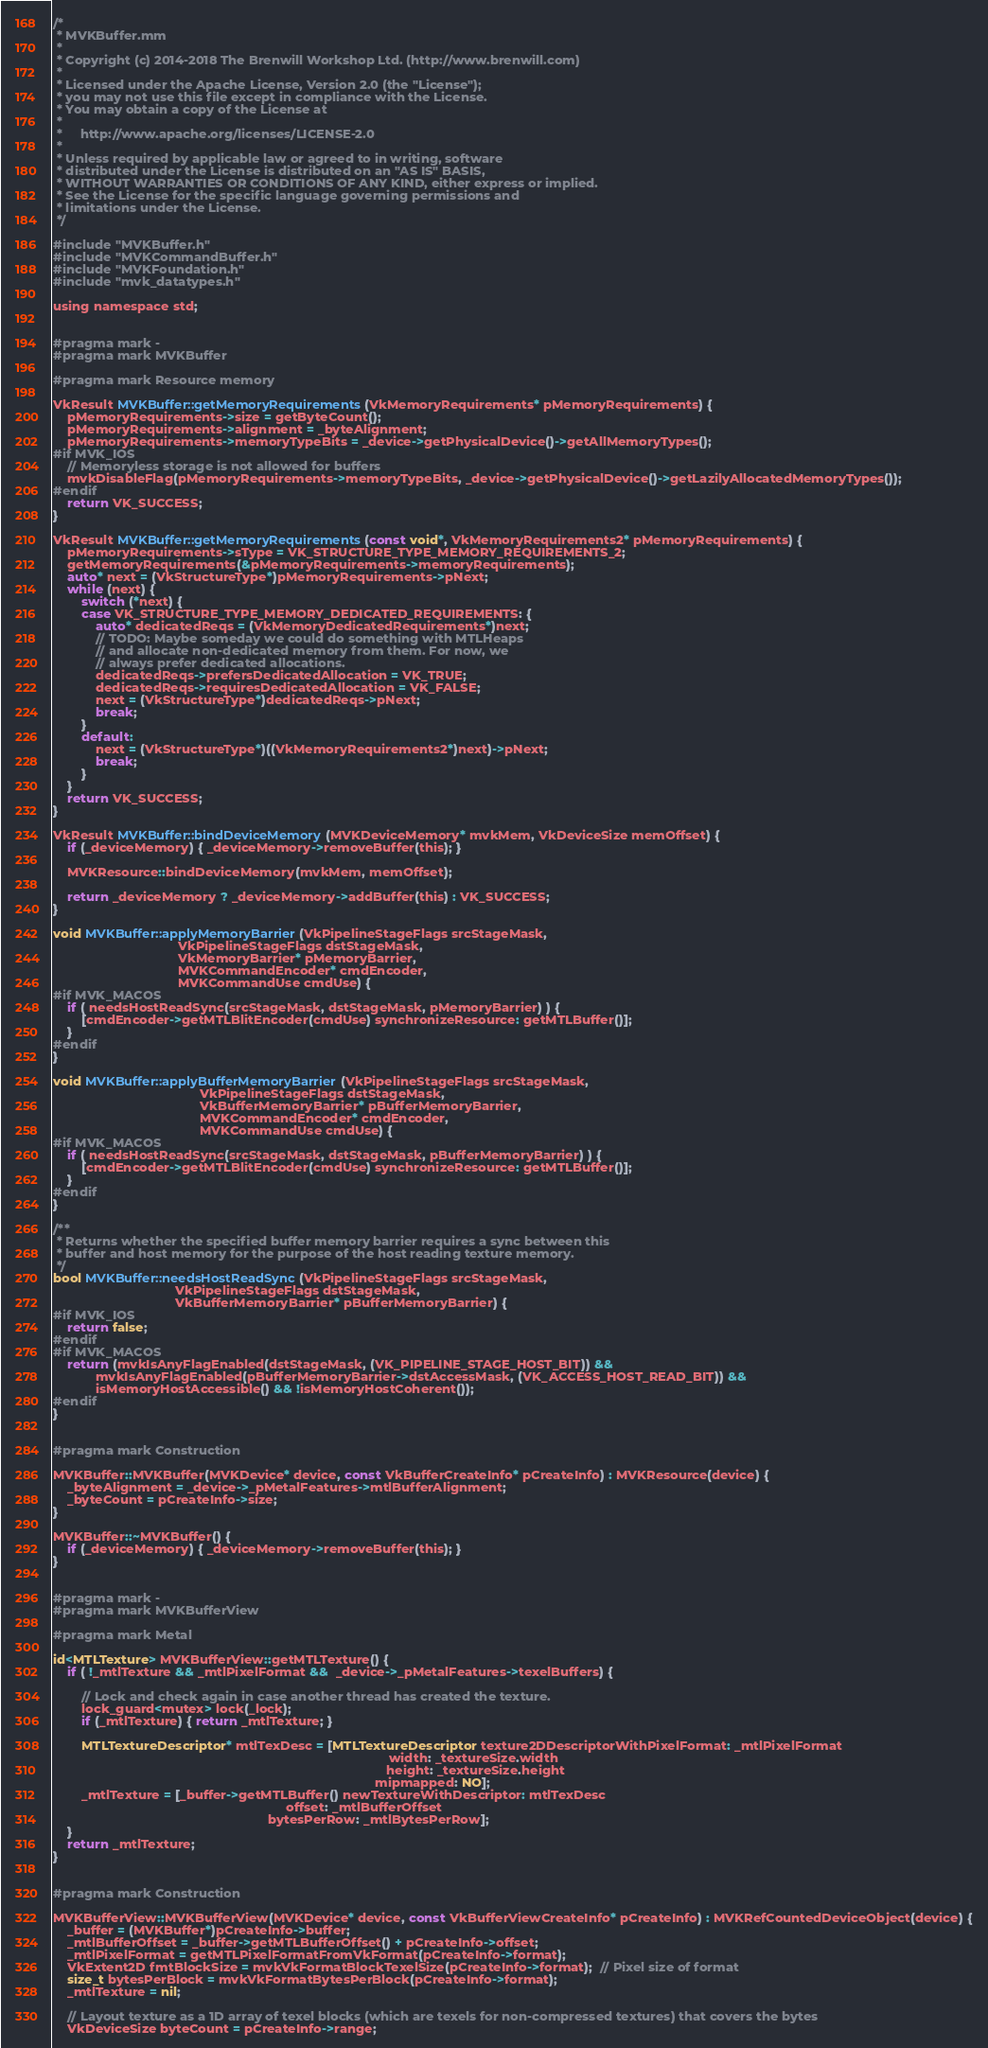Convert code to text. <code><loc_0><loc_0><loc_500><loc_500><_ObjectiveC_>/*
 * MVKBuffer.mm
 *
 * Copyright (c) 2014-2018 The Brenwill Workshop Ltd. (http://www.brenwill.com)
 *
 * Licensed under the Apache License, Version 2.0 (the "License");
 * you may not use this file except in compliance with the License.
 * You may obtain a copy of the License at
 * 
 *     http://www.apache.org/licenses/LICENSE-2.0
 * 
 * Unless required by applicable law or agreed to in writing, software
 * distributed under the License is distributed on an "AS IS" BASIS,
 * WITHOUT WARRANTIES OR CONDITIONS OF ANY KIND, either express or implied.
 * See the License for the specific language governing permissions and
 * limitations under the License.
 */

#include "MVKBuffer.h"
#include "MVKCommandBuffer.h"
#include "MVKFoundation.h"
#include "mvk_datatypes.h"

using namespace std;


#pragma mark -
#pragma mark MVKBuffer

#pragma mark Resource memory

VkResult MVKBuffer::getMemoryRequirements(VkMemoryRequirements* pMemoryRequirements) {
	pMemoryRequirements->size = getByteCount();
	pMemoryRequirements->alignment = _byteAlignment;
	pMemoryRequirements->memoryTypeBits = _device->getPhysicalDevice()->getAllMemoryTypes();
#if MVK_IOS
	// Memoryless storage is not allowed for buffers
	mvkDisableFlag(pMemoryRequirements->memoryTypeBits, _device->getPhysicalDevice()->getLazilyAllocatedMemoryTypes());
#endif
	return VK_SUCCESS;
}

VkResult MVKBuffer::getMemoryRequirements(const void*, VkMemoryRequirements2* pMemoryRequirements) {
	pMemoryRequirements->sType = VK_STRUCTURE_TYPE_MEMORY_REQUIREMENTS_2;
	getMemoryRequirements(&pMemoryRequirements->memoryRequirements);
	auto* next = (VkStructureType*)pMemoryRequirements->pNext;
	while (next) {
		switch (*next) {
		case VK_STRUCTURE_TYPE_MEMORY_DEDICATED_REQUIREMENTS: {
			auto* dedicatedReqs = (VkMemoryDedicatedRequirements*)next;
			// TODO: Maybe someday we could do something with MTLHeaps
			// and allocate non-dedicated memory from them. For now, we
			// always prefer dedicated allocations.
			dedicatedReqs->prefersDedicatedAllocation = VK_TRUE;
			dedicatedReqs->requiresDedicatedAllocation = VK_FALSE;
			next = (VkStructureType*)dedicatedReqs->pNext;
			break;
		}
		default:
			next = (VkStructureType*)((VkMemoryRequirements2*)next)->pNext;
			break;
		}
	}
	return VK_SUCCESS;
}

VkResult MVKBuffer::bindDeviceMemory(MVKDeviceMemory* mvkMem, VkDeviceSize memOffset) {
	if (_deviceMemory) { _deviceMemory->removeBuffer(this); }

	MVKResource::bindDeviceMemory(mvkMem, memOffset);

	return _deviceMemory ? _deviceMemory->addBuffer(this) : VK_SUCCESS;
}

void MVKBuffer::applyMemoryBarrier(VkPipelineStageFlags srcStageMask,
								   VkPipelineStageFlags dstStageMask,
								   VkMemoryBarrier* pMemoryBarrier,
                                   MVKCommandEncoder* cmdEncoder,
                                   MVKCommandUse cmdUse) {
#if MVK_MACOS
	if ( needsHostReadSync(srcStageMask, dstStageMask, pMemoryBarrier) ) {
		[cmdEncoder->getMTLBlitEncoder(cmdUse) synchronizeResource: getMTLBuffer()];
	}
#endif
}

void MVKBuffer::applyBufferMemoryBarrier(VkPipelineStageFlags srcStageMask,
										 VkPipelineStageFlags dstStageMask,
										 VkBufferMemoryBarrier* pBufferMemoryBarrier,
                                         MVKCommandEncoder* cmdEncoder,
                                         MVKCommandUse cmdUse) {
#if MVK_MACOS
	if ( needsHostReadSync(srcStageMask, dstStageMask, pBufferMemoryBarrier) ) {
		[cmdEncoder->getMTLBlitEncoder(cmdUse) synchronizeResource: getMTLBuffer()];
	}
#endif
}

/**
 * Returns whether the specified buffer memory barrier requires a sync between this
 * buffer and host memory for the purpose of the host reading texture memory.
 */
bool MVKBuffer::needsHostReadSync(VkPipelineStageFlags srcStageMask,
								  VkPipelineStageFlags dstStageMask,
								  VkBufferMemoryBarrier* pBufferMemoryBarrier) {
#if MVK_IOS
	return false;
#endif
#if MVK_MACOS
	return (mvkIsAnyFlagEnabled(dstStageMask, (VK_PIPELINE_STAGE_HOST_BIT)) &&
			mvkIsAnyFlagEnabled(pBufferMemoryBarrier->dstAccessMask, (VK_ACCESS_HOST_READ_BIT)) &&
			isMemoryHostAccessible() && !isMemoryHostCoherent());
#endif
}


#pragma mark Construction

MVKBuffer::MVKBuffer(MVKDevice* device, const VkBufferCreateInfo* pCreateInfo) : MVKResource(device) {
    _byteAlignment = _device->_pMetalFeatures->mtlBufferAlignment;
    _byteCount = pCreateInfo->size;
}

MVKBuffer::~MVKBuffer() {
	if (_deviceMemory) { _deviceMemory->removeBuffer(this); }
}


#pragma mark -
#pragma mark MVKBufferView

#pragma mark Metal

id<MTLTexture> MVKBufferView::getMTLTexture() {
    if ( !_mtlTexture && _mtlPixelFormat &&  _device->_pMetalFeatures->texelBuffers) {

		// Lock and check again in case another thread has created the texture.
		lock_guard<mutex> lock(_lock);
		if (_mtlTexture) { return _mtlTexture; }

        MTLTextureDescriptor* mtlTexDesc = [MTLTextureDescriptor texture2DDescriptorWithPixelFormat: _mtlPixelFormat
                                                                                              width: _textureSize.width
                                                                                             height: _textureSize.height
                                                                                          mipmapped: NO];
		_mtlTexture = [_buffer->getMTLBuffer() newTextureWithDescriptor: mtlTexDesc
																 offset: _mtlBufferOffset
															bytesPerRow: _mtlBytesPerRow];
    }
    return _mtlTexture;
}


#pragma mark Construction

MVKBufferView::MVKBufferView(MVKDevice* device, const VkBufferViewCreateInfo* pCreateInfo) : MVKRefCountedDeviceObject(device) {
    _buffer = (MVKBuffer*)pCreateInfo->buffer;
    _mtlBufferOffset = _buffer->getMTLBufferOffset() + pCreateInfo->offset;
    _mtlPixelFormat = getMTLPixelFormatFromVkFormat(pCreateInfo->format);
    VkExtent2D fmtBlockSize = mvkVkFormatBlockTexelSize(pCreateInfo->format);  // Pixel size of format
    size_t bytesPerBlock = mvkVkFormatBytesPerBlock(pCreateInfo->format);
	_mtlTexture = nil;

    // Layout texture as a 1D array of texel blocks (which are texels for non-compressed textures) that covers the bytes
    VkDeviceSize byteCount = pCreateInfo->range;</code> 